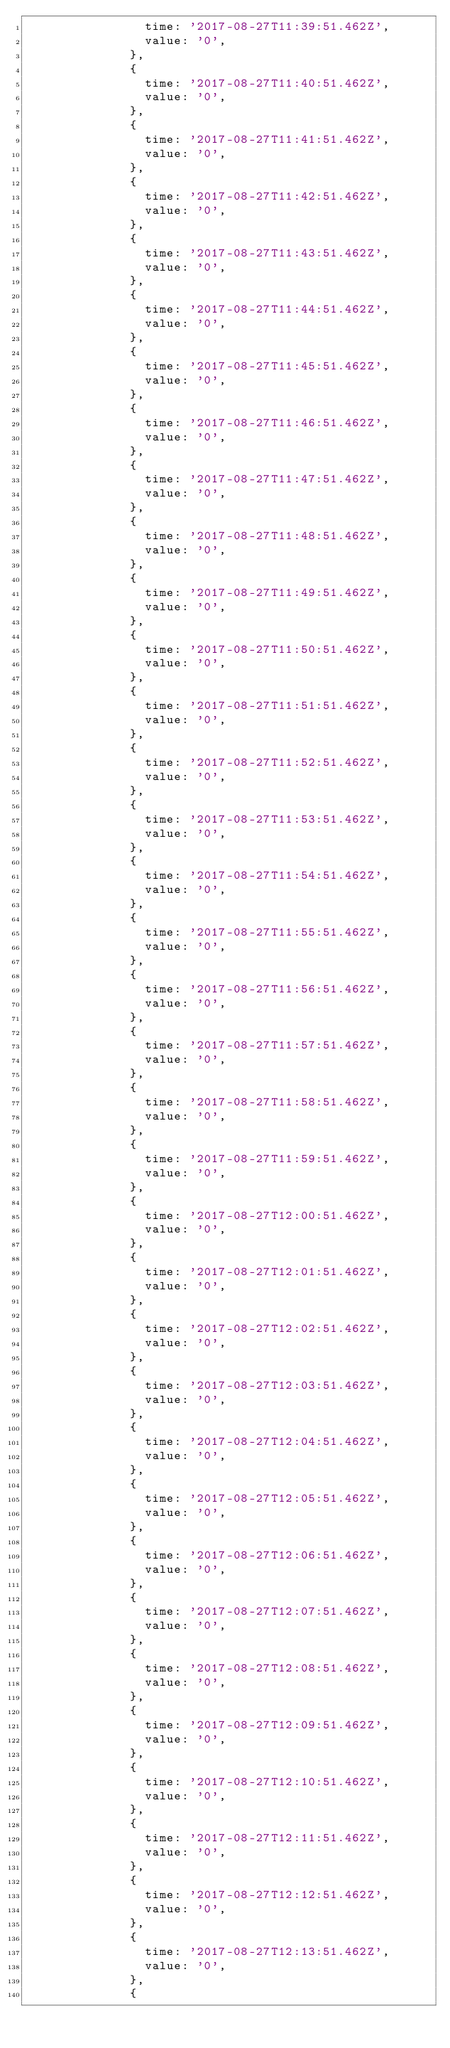Convert code to text. <code><loc_0><loc_0><loc_500><loc_500><_JavaScript_>                time: '2017-08-27T11:39:51.462Z',
                value: '0',
              },
              {
                time: '2017-08-27T11:40:51.462Z',
                value: '0',
              },
              {
                time: '2017-08-27T11:41:51.462Z',
                value: '0',
              },
              {
                time: '2017-08-27T11:42:51.462Z',
                value: '0',
              },
              {
                time: '2017-08-27T11:43:51.462Z',
                value: '0',
              },
              {
                time: '2017-08-27T11:44:51.462Z',
                value: '0',
              },
              {
                time: '2017-08-27T11:45:51.462Z',
                value: '0',
              },
              {
                time: '2017-08-27T11:46:51.462Z',
                value: '0',
              },
              {
                time: '2017-08-27T11:47:51.462Z',
                value: '0',
              },
              {
                time: '2017-08-27T11:48:51.462Z',
                value: '0',
              },
              {
                time: '2017-08-27T11:49:51.462Z',
                value: '0',
              },
              {
                time: '2017-08-27T11:50:51.462Z',
                value: '0',
              },
              {
                time: '2017-08-27T11:51:51.462Z',
                value: '0',
              },
              {
                time: '2017-08-27T11:52:51.462Z',
                value: '0',
              },
              {
                time: '2017-08-27T11:53:51.462Z',
                value: '0',
              },
              {
                time: '2017-08-27T11:54:51.462Z',
                value: '0',
              },
              {
                time: '2017-08-27T11:55:51.462Z',
                value: '0',
              },
              {
                time: '2017-08-27T11:56:51.462Z',
                value: '0',
              },
              {
                time: '2017-08-27T11:57:51.462Z',
                value: '0',
              },
              {
                time: '2017-08-27T11:58:51.462Z',
                value: '0',
              },
              {
                time: '2017-08-27T11:59:51.462Z',
                value: '0',
              },
              {
                time: '2017-08-27T12:00:51.462Z',
                value: '0',
              },
              {
                time: '2017-08-27T12:01:51.462Z',
                value: '0',
              },
              {
                time: '2017-08-27T12:02:51.462Z',
                value: '0',
              },
              {
                time: '2017-08-27T12:03:51.462Z',
                value: '0',
              },
              {
                time: '2017-08-27T12:04:51.462Z',
                value: '0',
              },
              {
                time: '2017-08-27T12:05:51.462Z',
                value: '0',
              },
              {
                time: '2017-08-27T12:06:51.462Z',
                value: '0',
              },
              {
                time: '2017-08-27T12:07:51.462Z',
                value: '0',
              },
              {
                time: '2017-08-27T12:08:51.462Z',
                value: '0',
              },
              {
                time: '2017-08-27T12:09:51.462Z',
                value: '0',
              },
              {
                time: '2017-08-27T12:10:51.462Z',
                value: '0',
              },
              {
                time: '2017-08-27T12:11:51.462Z',
                value: '0',
              },
              {
                time: '2017-08-27T12:12:51.462Z',
                value: '0',
              },
              {
                time: '2017-08-27T12:13:51.462Z',
                value: '0',
              },
              {</code> 